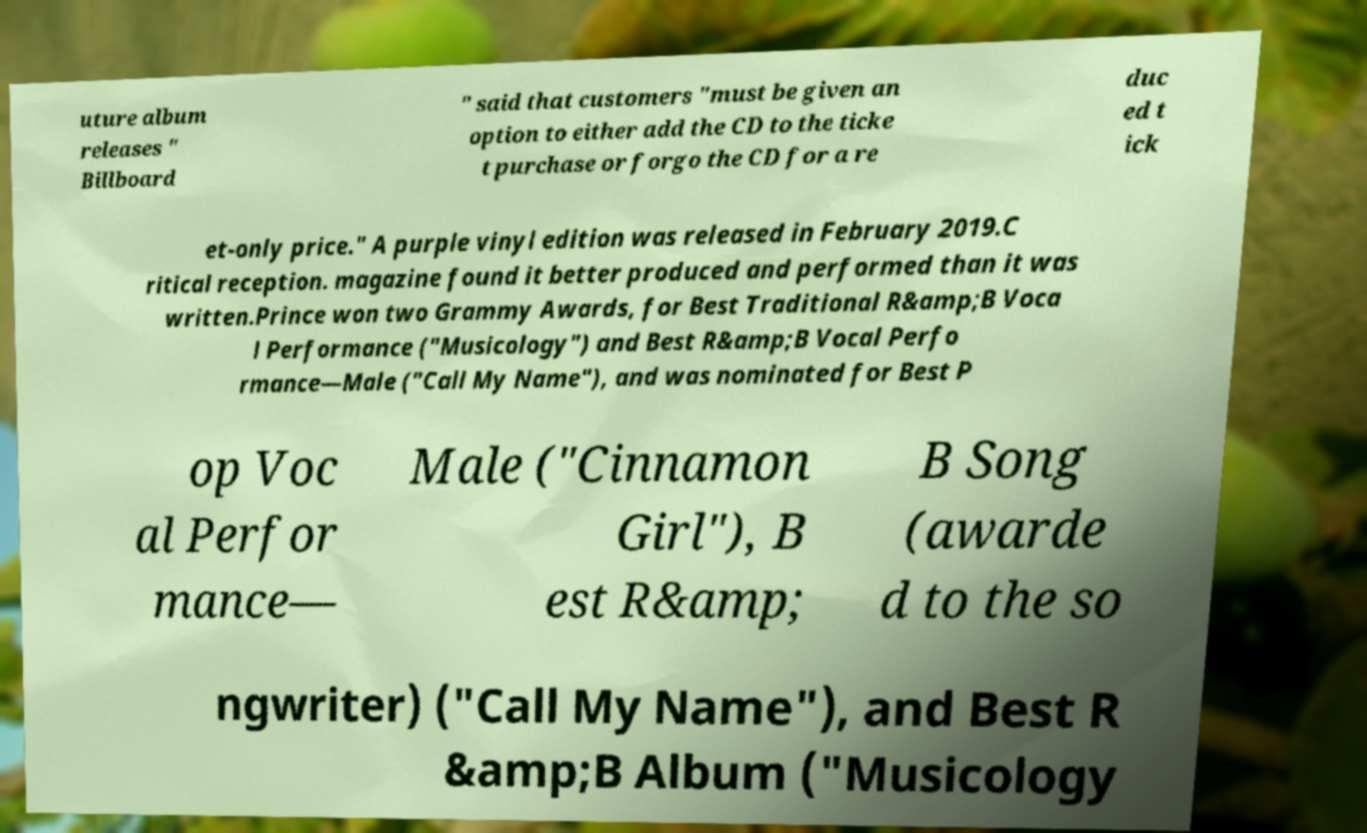Can you read and provide the text displayed in the image?This photo seems to have some interesting text. Can you extract and type it out for me? uture album releases " Billboard " said that customers "must be given an option to either add the CD to the ticke t purchase or forgo the CD for a re duc ed t ick et-only price." A purple vinyl edition was released in February 2019.C ritical reception. magazine found it better produced and performed than it was written.Prince won two Grammy Awards, for Best Traditional R&amp;B Voca l Performance ("Musicology") and Best R&amp;B Vocal Perfo rmance—Male ("Call My Name"), and was nominated for Best P op Voc al Perfor mance— Male ("Cinnamon Girl"), B est R&amp; B Song (awarde d to the so ngwriter) ("Call My Name"), and Best R &amp;B Album ("Musicology 